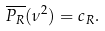<formula> <loc_0><loc_0><loc_500><loc_500>\overline { P _ { R } } ( \nu ^ { 2 } ) = c _ { R } .</formula> 